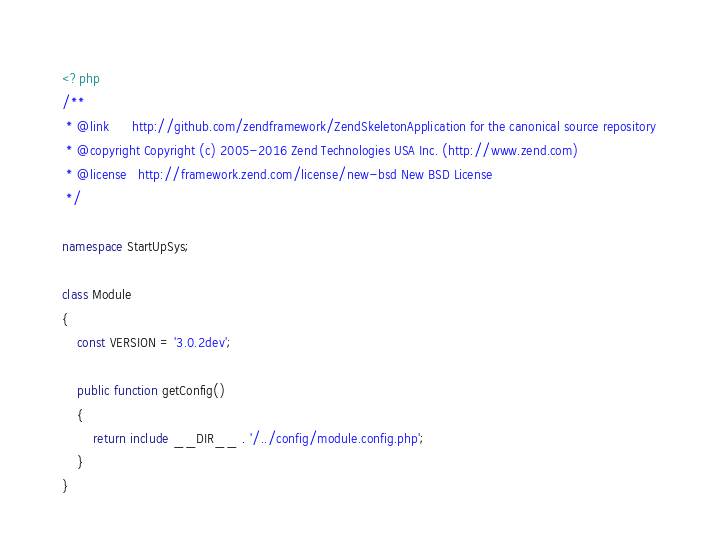Convert code to text. <code><loc_0><loc_0><loc_500><loc_500><_PHP_><?php
/**
 * @link      http://github.com/zendframework/ZendSkeletonApplication for the canonical source repository
 * @copyright Copyright (c) 2005-2016 Zend Technologies USA Inc. (http://www.zend.com)
 * @license   http://framework.zend.com/license/new-bsd New BSD License
 */

namespace StartUpSys;

class Module
{
    const VERSION = '3.0.2dev';

    public function getConfig()
    {
        return include __DIR__ . '/../config/module.config.php';
    }
}
</code> 